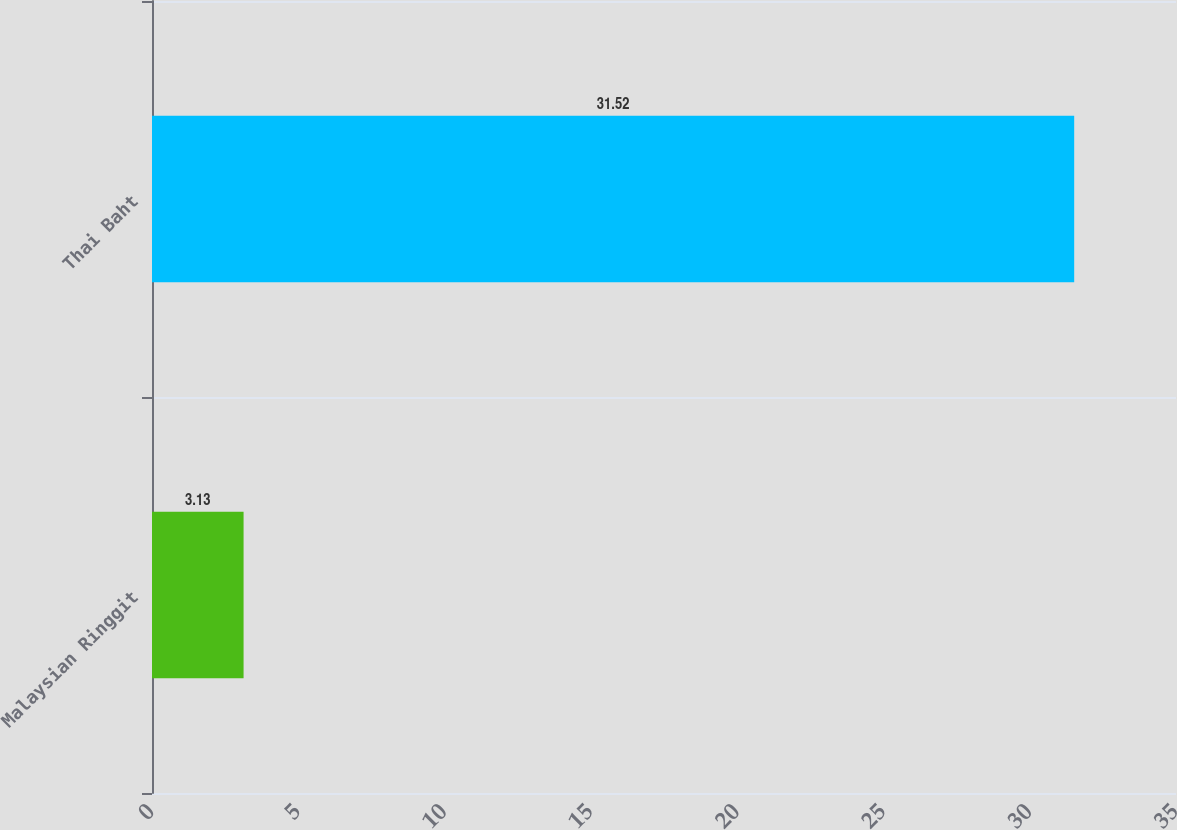<chart> <loc_0><loc_0><loc_500><loc_500><bar_chart><fcel>Malaysian Ringgit<fcel>Thai Baht<nl><fcel>3.13<fcel>31.52<nl></chart> 